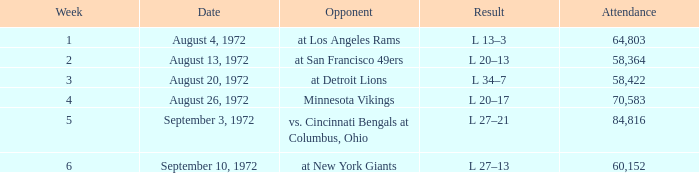Write the full table. {'header': ['Week', 'Date', 'Opponent', 'Result', 'Attendance'], 'rows': [['1', 'August 4, 1972', 'at Los Angeles Rams', 'L 13–3', '64,803'], ['2', 'August 13, 1972', 'at San Francisco 49ers', 'L 20–13', '58,364'], ['3', 'August 20, 1972', 'at Detroit Lions', 'L 34–7', '58,422'], ['4', 'August 26, 1972', 'Minnesota Vikings', 'L 20–17', '70,583'], ['5', 'September 3, 1972', 'vs. Cincinnati Bengals at Columbus, Ohio', 'L 27–21', '84,816'], ['6', 'September 10, 1972', 'at New York Giants', 'L 27–13', '60,152']]} What is the date of week 4? August 26, 1972. 